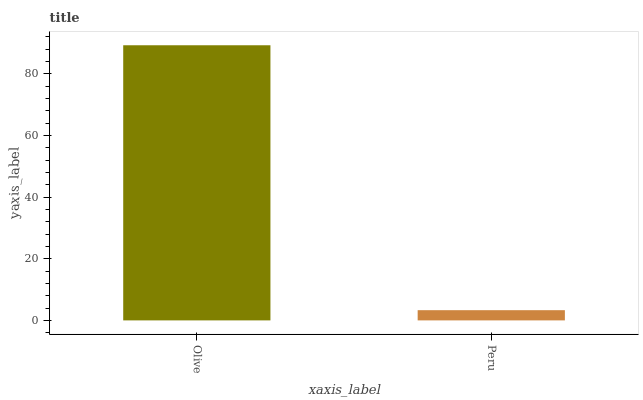Is Peru the minimum?
Answer yes or no. Yes. Is Olive the maximum?
Answer yes or no. Yes. Is Peru the maximum?
Answer yes or no. No. Is Olive greater than Peru?
Answer yes or no. Yes. Is Peru less than Olive?
Answer yes or no. Yes. Is Peru greater than Olive?
Answer yes or no. No. Is Olive less than Peru?
Answer yes or no. No. Is Olive the high median?
Answer yes or no. Yes. Is Peru the low median?
Answer yes or no. Yes. Is Peru the high median?
Answer yes or no. No. Is Olive the low median?
Answer yes or no. No. 